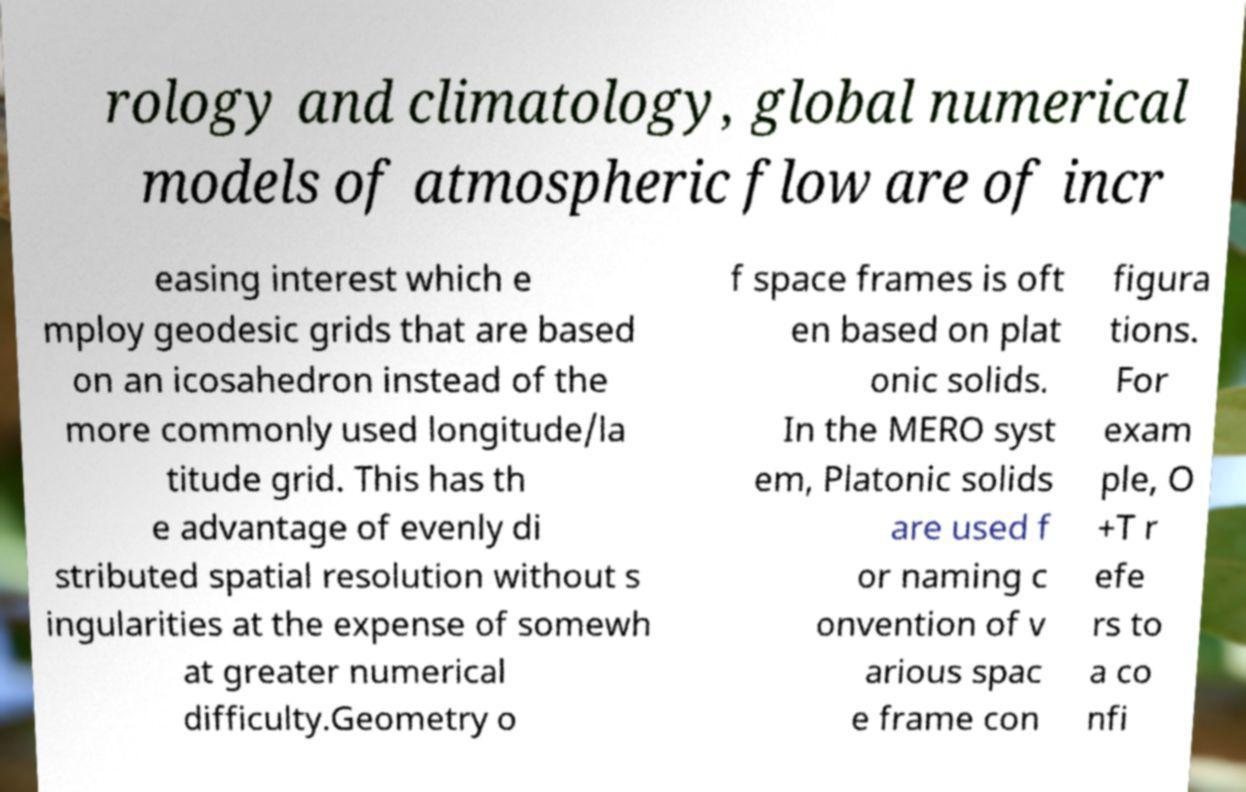Can you read and provide the text displayed in the image?This photo seems to have some interesting text. Can you extract and type it out for me? rology and climatology, global numerical models of atmospheric flow are of incr easing interest which e mploy geodesic grids that are based on an icosahedron instead of the more commonly used longitude/la titude grid. This has th e advantage of evenly di stributed spatial resolution without s ingularities at the expense of somewh at greater numerical difficulty.Geometry o f space frames is oft en based on plat onic solids. In the MERO syst em, Platonic solids are used f or naming c onvention of v arious spac e frame con figura tions. For exam ple, O +T r efe rs to a co nfi 